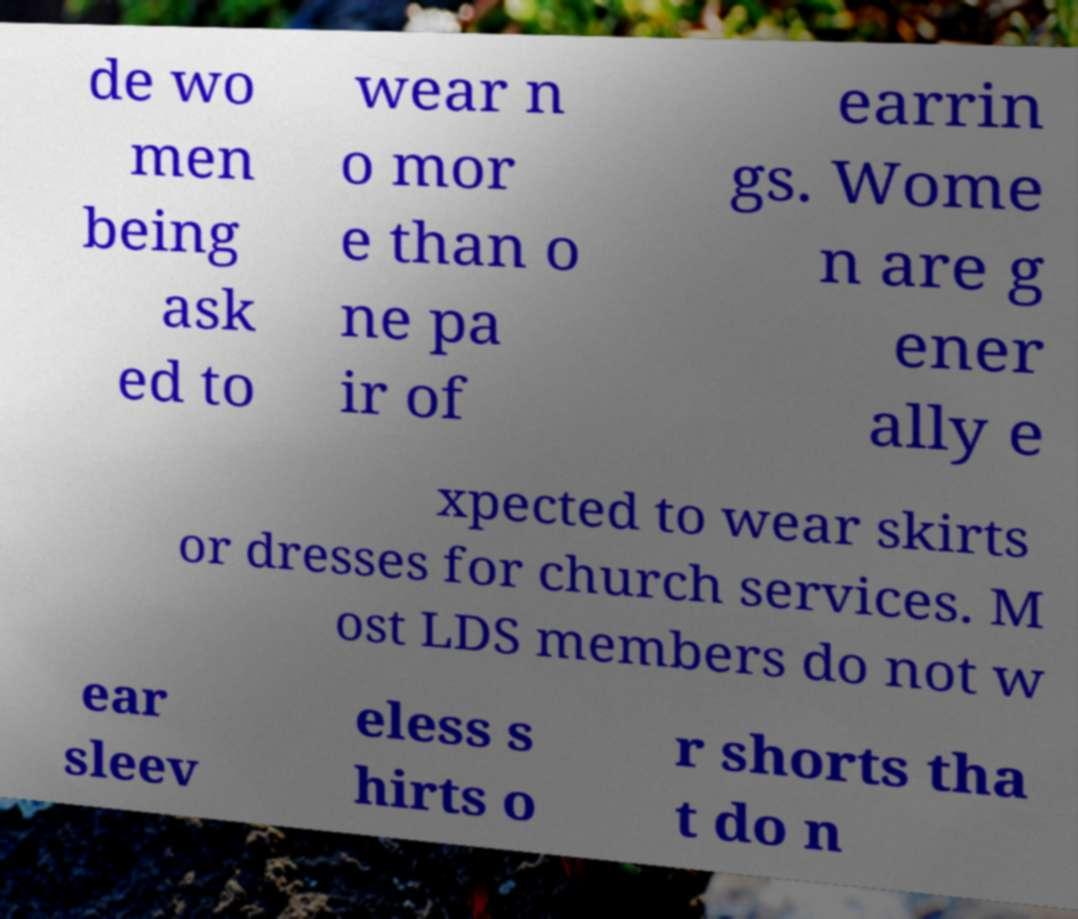Could you assist in decoding the text presented in this image and type it out clearly? de wo men being ask ed to wear n o mor e than o ne pa ir of earrin gs. Wome n are g ener ally e xpected to wear skirts or dresses for church services. M ost LDS members do not w ear sleev eless s hirts o r shorts tha t do n 